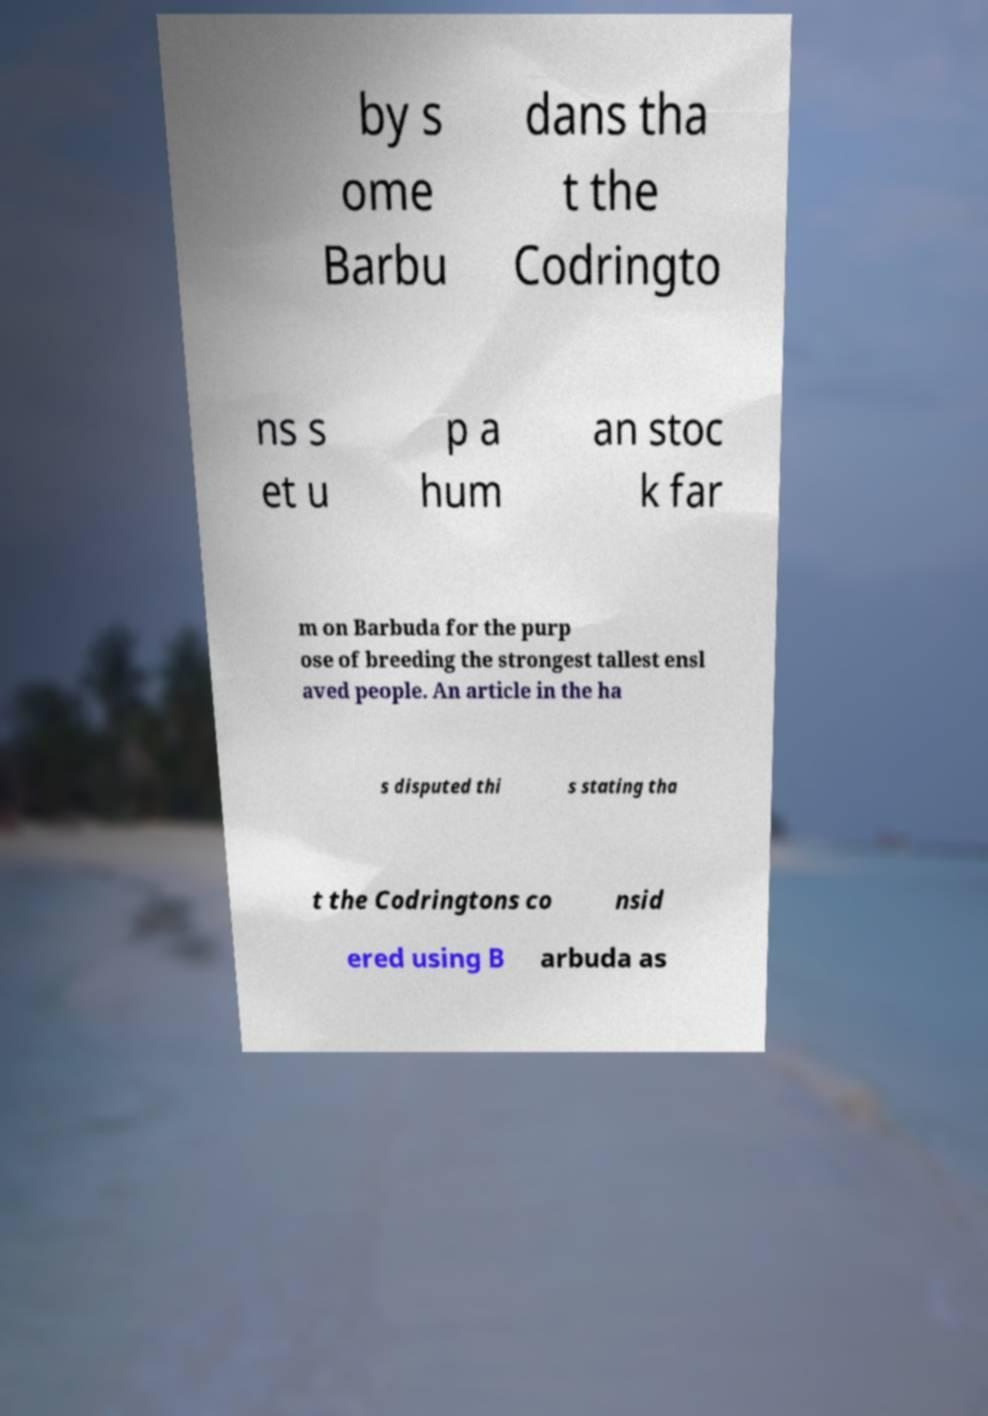Can you read and provide the text displayed in the image?This photo seems to have some interesting text. Can you extract and type it out for me? by s ome Barbu dans tha t the Codringto ns s et u p a hum an stoc k far m on Barbuda for the purp ose of breeding the strongest tallest ensl aved people. An article in the ha s disputed thi s stating tha t the Codringtons co nsid ered using B arbuda as 